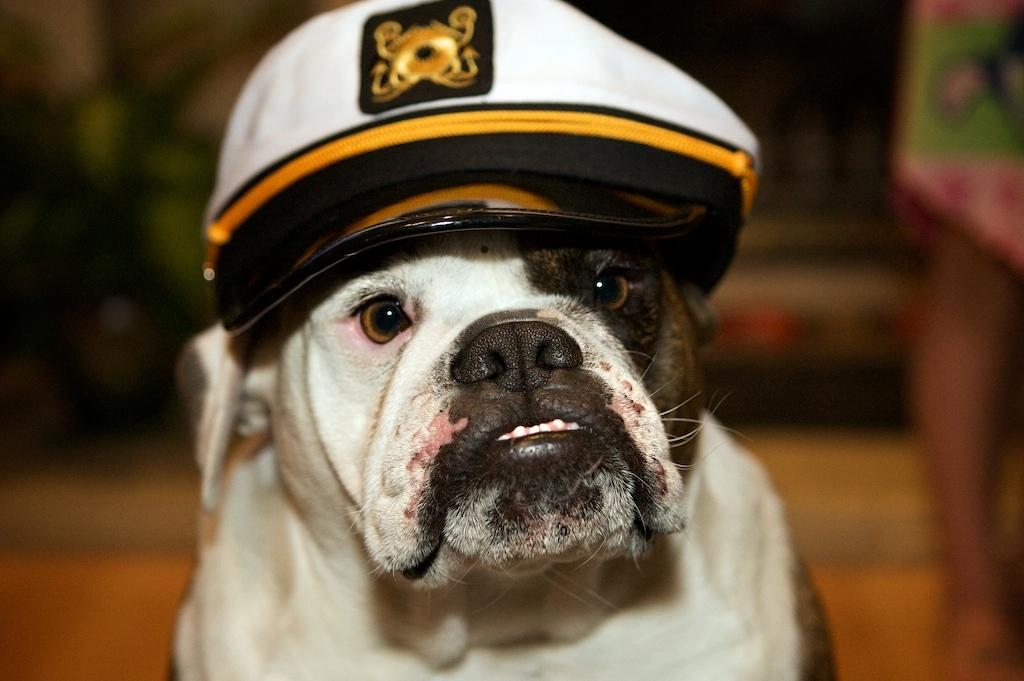What type of animal is in the image? There is a white dog in the image. What is the dog wearing? The dog is wearing a cap. What is the background of the image? There is a background of dirt or bur in the image. Can you describe the person in the image? There is a person standing on the right side of the image. What type of stove can be seen in the image? There is no stove present in the image. Is the dog in motion in the image? The dog is not in motion in the image; it is stationary. 